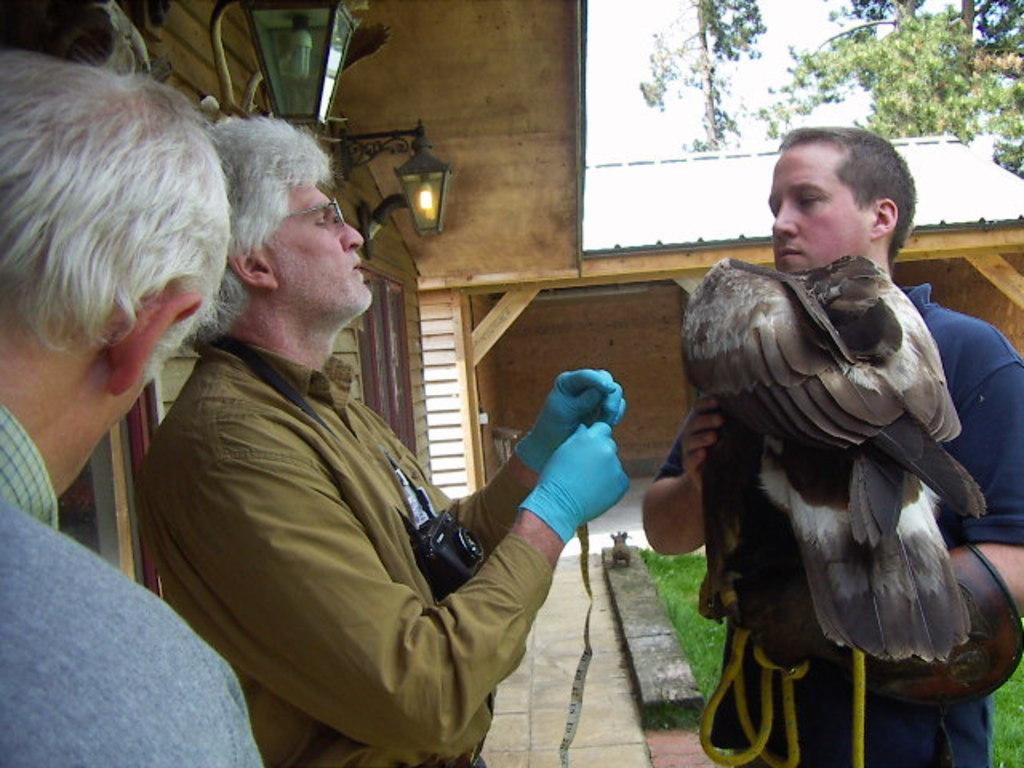How many people are in the image? There are people in the image, but the exact number is not specified. What is one person holding in the image? One person is holding a bird in the image. What is another person holding in the image? Another person is holding an injector in the image. What can be seen in the background of the image? There is a house, a tree, and grass in the background of the image. What day of the week is depicted in the image? The day of the week is not depicted in the image; there is no reference to time or date. 